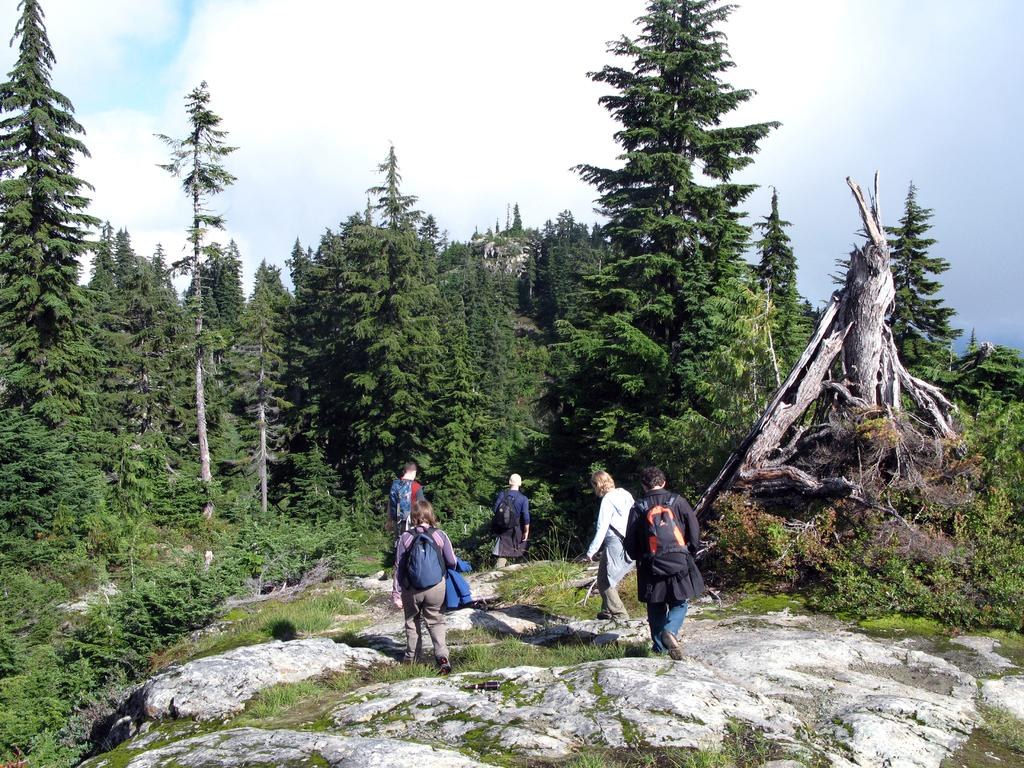What type of setting is depicted in the image? The image is an outdoor scene. What are the people in the image doing? The people in the image are walking. What are the people carrying with them? The people have bags. What type of vegetation can be seen in the image? There are trees visible in the image. What is the ground covered with in the image? There is grass visible in the image. What type of trade is happening between the people in the image? There is no indication of any trade happening between the people in the image. Can you see a donkey in the image? No, there is no donkey present in the image. 